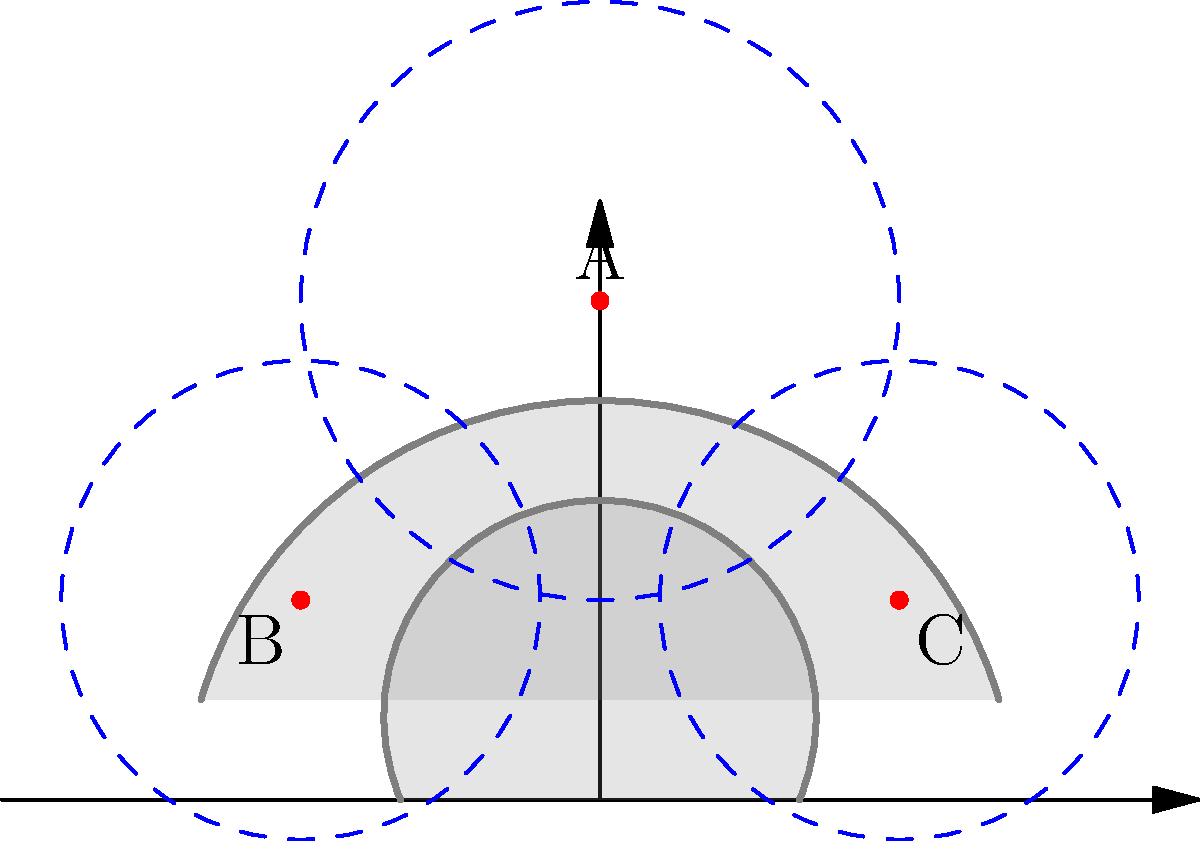In the topological analysis of radio network coverage in mountainous terrain, as shown in the diagram, three radio towers (A, B, and C) are positioned to cover a mountainous area. Given the placement of these towers and their coverage areas (represented by dashed circles), which topological property best describes the relationship between the coverage areas of towers A and B? To determine the topological relationship between the coverage areas of towers A and B, we need to analyze their interaction in the given mountainous terrain. Let's follow these steps:

1. Observe the positions of towers A and B:
   - Tower A is located at the highest point (0, 2.5)
   - Tower B is located at (-1.5, 1)

2. Examine the coverage areas:
   - Tower A's coverage is represented by the largest dashed circle
   - Tower B's coverage is represented by the left smaller dashed circle

3. Analyze the interaction between the coverage areas:
   - The coverage areas of A and B overlap partially
   - There is a significant shared region between the two coverage areas
   - However, each coverage area also has regions that are not covered by the other

4. Consider the effect of the mountainous terrain:
   - The mountain range between A and B may partially obstruct the signal
   - This obstruction doesn't completely separate the coverage areas

5. Identify the topological relationship:
   - The coverage areas are neither completely separate nor fully contained within each other
   - They share a common region while maintaining distinct areas

6. Conclude the topological property:
   - The relationship between the coverage areas of towers A and B is best described as "intersection"

This intersection allows for signal handover between the two towers in the overlapping region, which is crucial for maintaining continuous coverage in mountainous terrain.
Answer: Intersection 